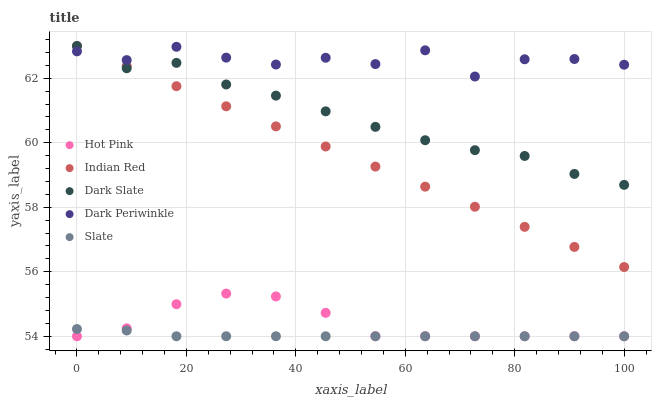Does Slate have the minimum area under the curve?
Answer yes or no. Yes. Does Dark Periwinkle have the maximum area under the curve?
Answer yes or no. Yes. Does Hot Pink have the minimum area under the curve?
Answer yes or no. No. Does Hot Pink have the maximum area under the curve?
Answer yes or no. No. Is Indian Red the smoothest?
Answer yes or no. Yes. Is Dark Periwinkle the roughest?
Answer yes or no. Yes. Is Slate the smoothest?
Answer yes or no. No. Is Slate the roughest?
Answer yes or no. No. Does Slate have the lowest value?
Answer yes or no. Yes. Does Dark Periwinkle have the lowest value?
Answer yes or no. No. Does Indian Red have the highest value?
Answer yes or no. Yes. Does Hot Pink have the highest value?
Answer yes or no. No. Is Slate less than Dark Slate?
Answer yes or no. Yes. Is Dark Periwinkle greater than Hot Pink?
Answer yes or no. Yes. Does Dark Periwinkle intersect Dark Slate?
Answer yes or no. Yes. Is Dark Periwinkle less than Dark Slate?
Answer yes or no. No. Is Dark Periwinkle greater than Dark Slate?
Answer yes or no. No. Does Slate intersect Dark Slate?
Answer yes or no. No. 